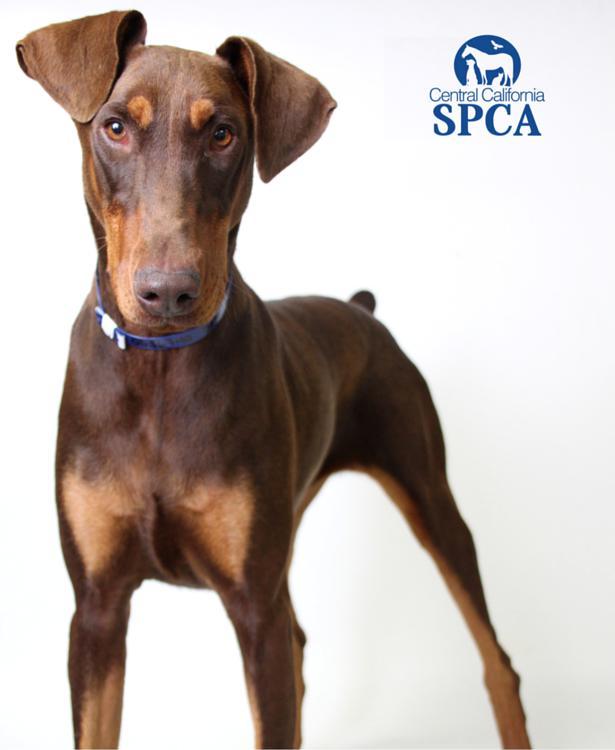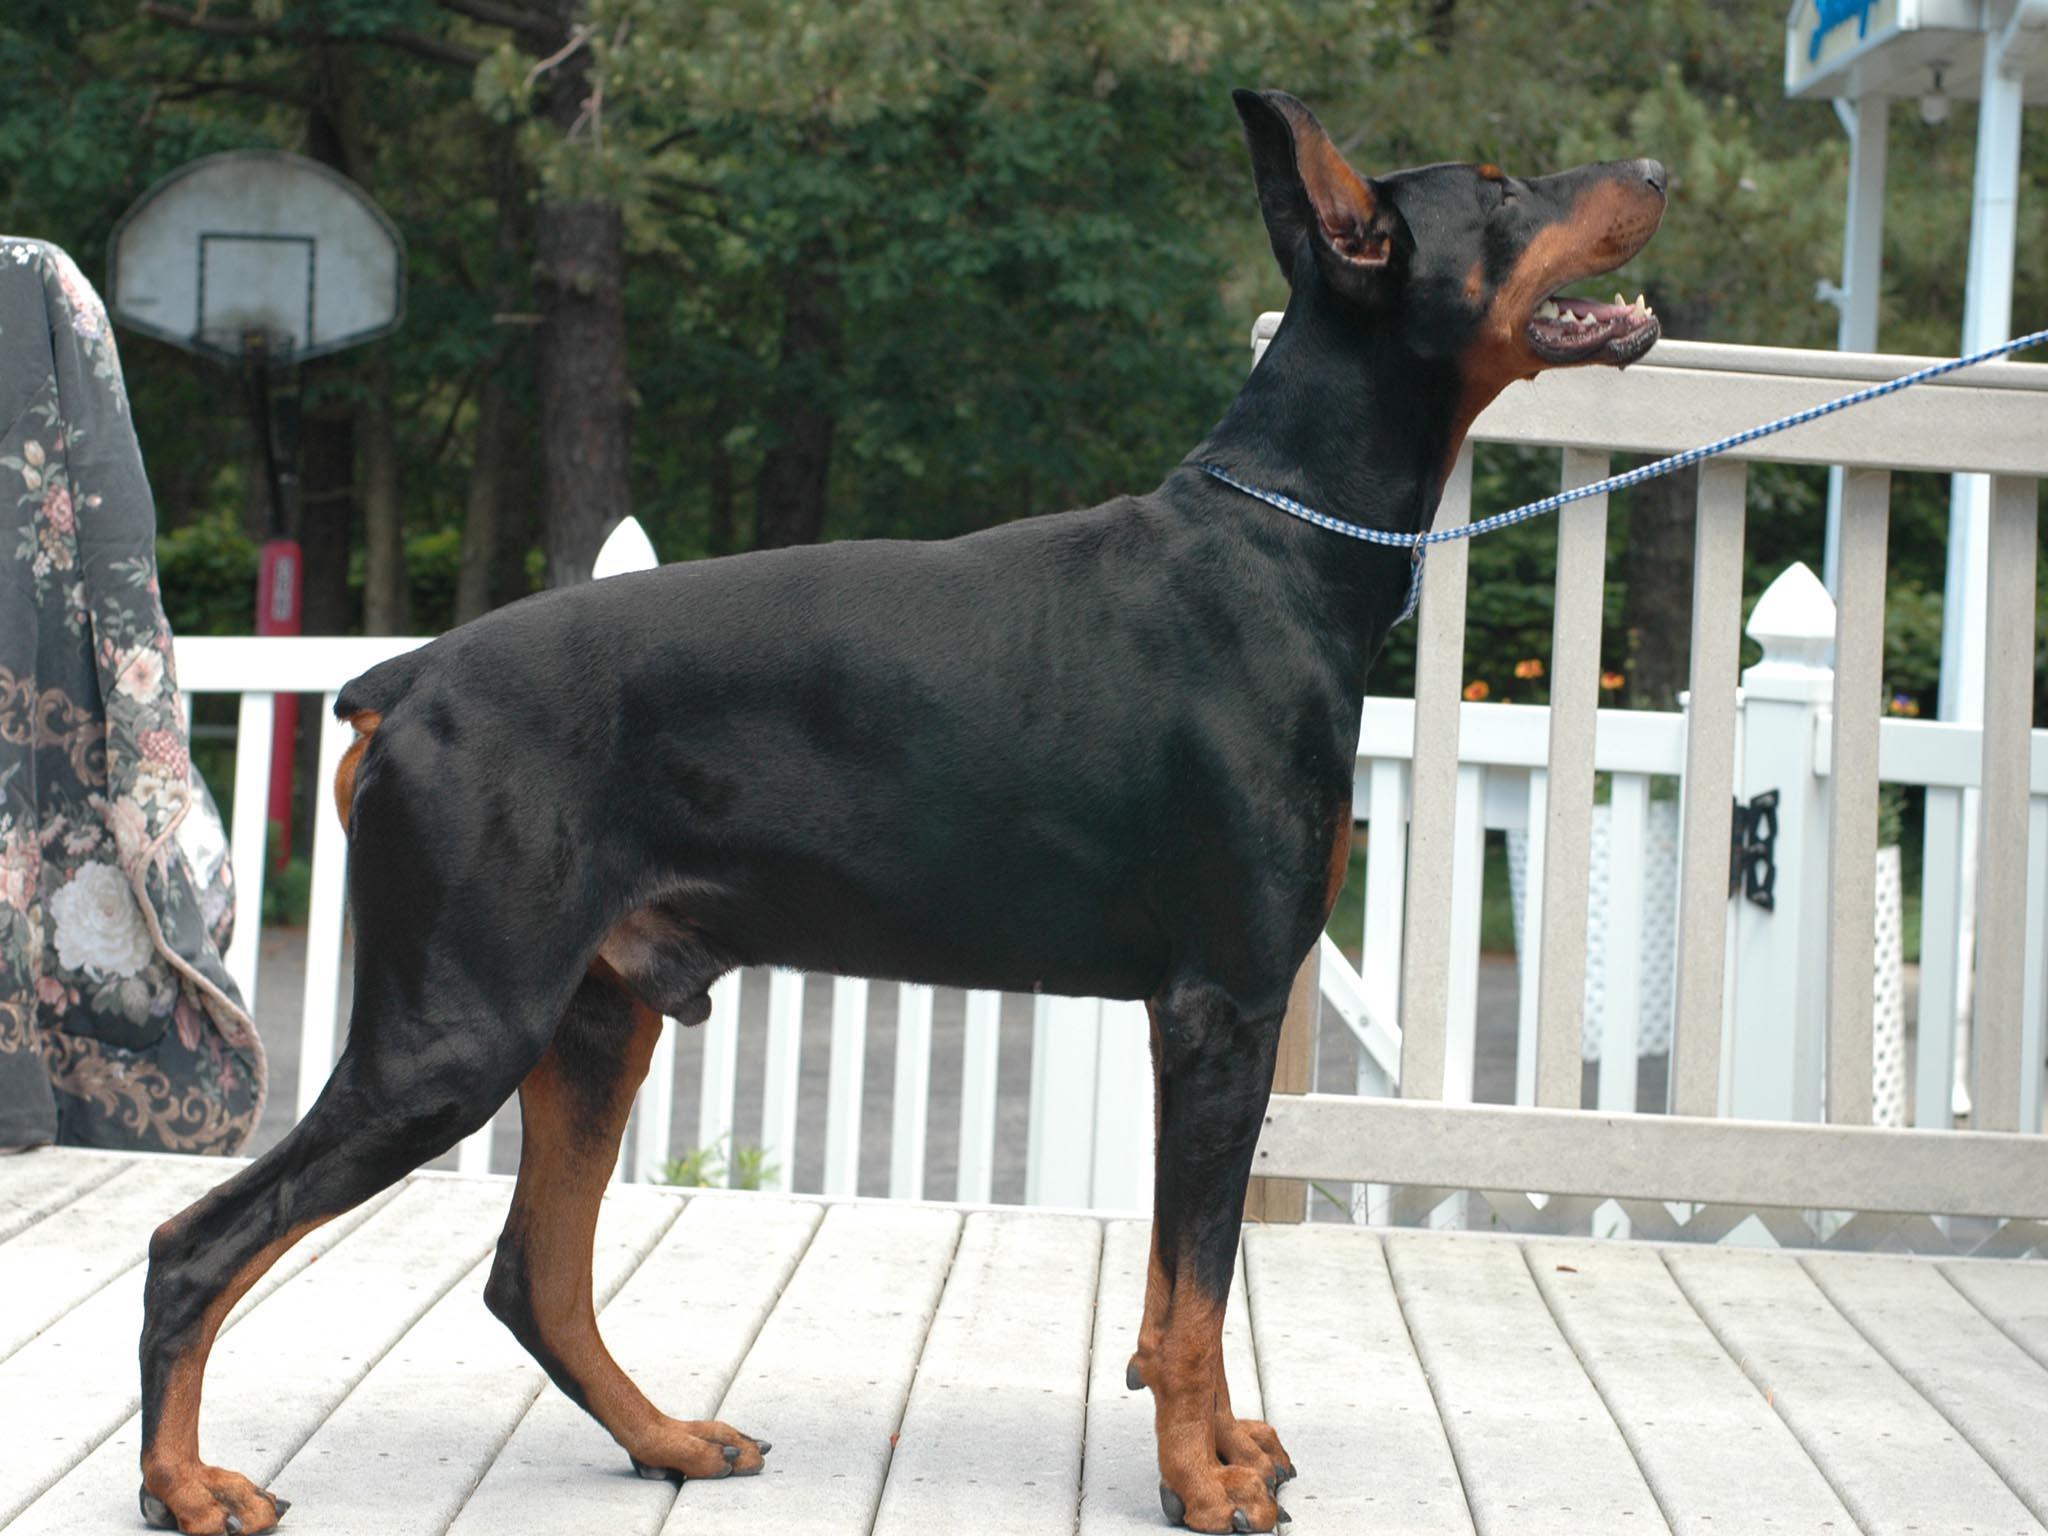The first image is the image on the left, the second image is the image on the right. Analyze the images presented: Is the assertion "Each image contains one doberman with erect ears, and the left image features a doberman standing with its head and body angled leftward." valid? Answer yes or no. No. The first image is the image on the left, the second image is the image on the right. Analyze the images presented: Is the assertion "there is a doberman with a taught leash attached to it's collar" valid? Answer yes or no. Yes. 